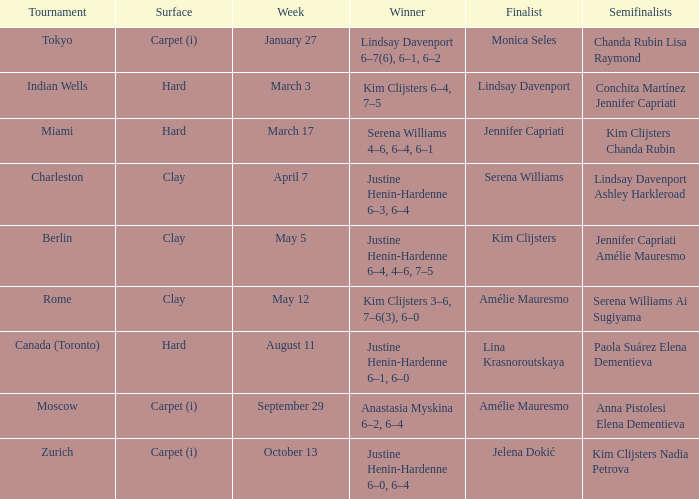In miami, who was the ultimate competitor? Jennifer Capriati. 